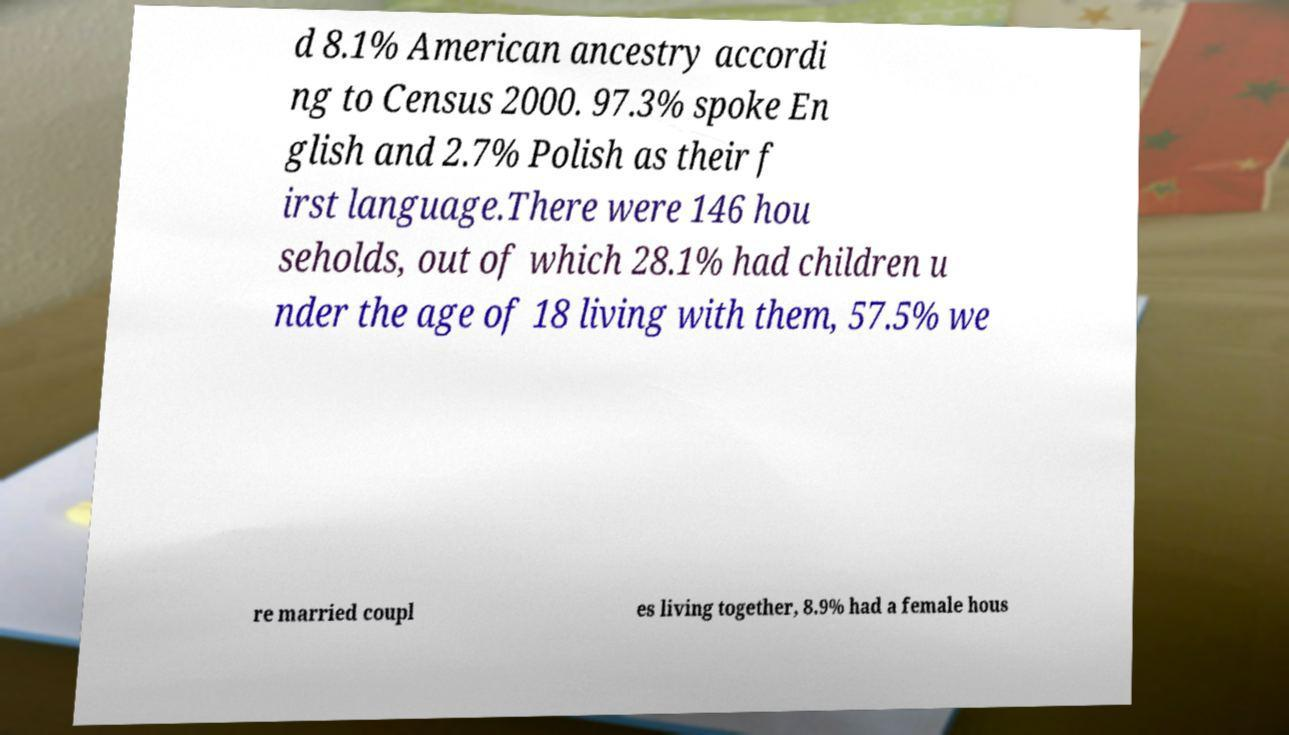There's text embedded in this image that I need extracted. Can you transcribe it verbatim? d 8.1% American ancestry accordi ng to Census 2000. 97.3% spoke En glish and 2.7% Polish as their f irst language.There were 146 hou seholds, out of which 28.1% had children u nder the age of 18 living with them, 57.5% we re married coupl es living together, 8.9% had a female hous 